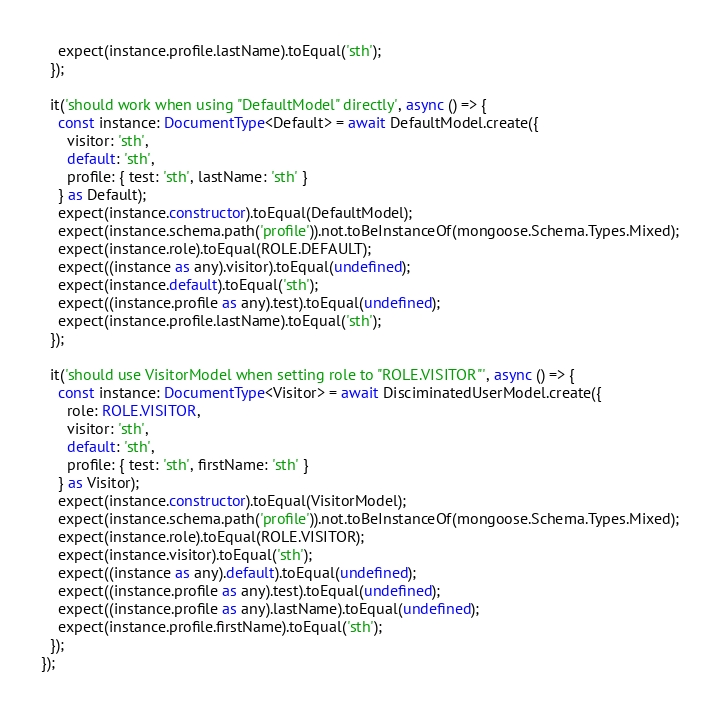Convert code to text. <code><loc_0><loc_0><loc_500><loc_500><_TypeScript_>    expect(instance.profile.lastName).toEqual('sth');
  });

  it('should work when using "DefaultModel" directly', async () => {
    const instance: DocumentType<Default> = await DefaultModel.create({
      visitor: 'sth',
      default: 'sth',
      profile: { test: 'sth', lastName: 'sth' }
    } as Default);
    expect(instance.constructor).toEqual(DefaultModel);
    expect(instance.schema.path('profile')).not.toBeInstanceOf(mongoose.Schema.Types.Mixed);
    expect(instance.role).toEqual(ROLE.DEFAULT);
    expect((instance as any).visitor).toEqual(undefined);
    expect(instance.default).toEqual('sth');
    expect((instance.profile as any).test).toEqual(undefined);
    expect(instance.profile.lastName).toEqual('sth');
  });

  it('should use VisitorModel when setting role to "ROLE.VISITOR"', async () => {
    const instance: DocumentType<Visitor> = await DisciminatedUserModel.create({
      role: ROLE.VISITOR,
      visitor: 'sth',
      default: 'sth',
      profile: { test: 'sth', firstName: 'sth' }
    } as Visitor);
    expect(instance.constructor).toEqual(VisitorModel);
    expect(instance.schema.path('profile')).not.toBeInstanceOf(mongoose.Schema.Types.Mixed);
    expect(instance.role).toEqual(ROLE.VISITOR);
    expect(instance.visitor).toEqual('sth');
    expect((instance as any).default).toEqual(undefined);
    expect((instance.profile as any).test).toEqual(undefined);
    expect((instance.profile as any).lastName).toEqual(undefined);
    expect(instance.profile.firstName).toEqual('sth');
  });
});
</code> 